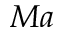<formula> <loc_0><loc_0><loc_500><loc_500>M a</formula> 